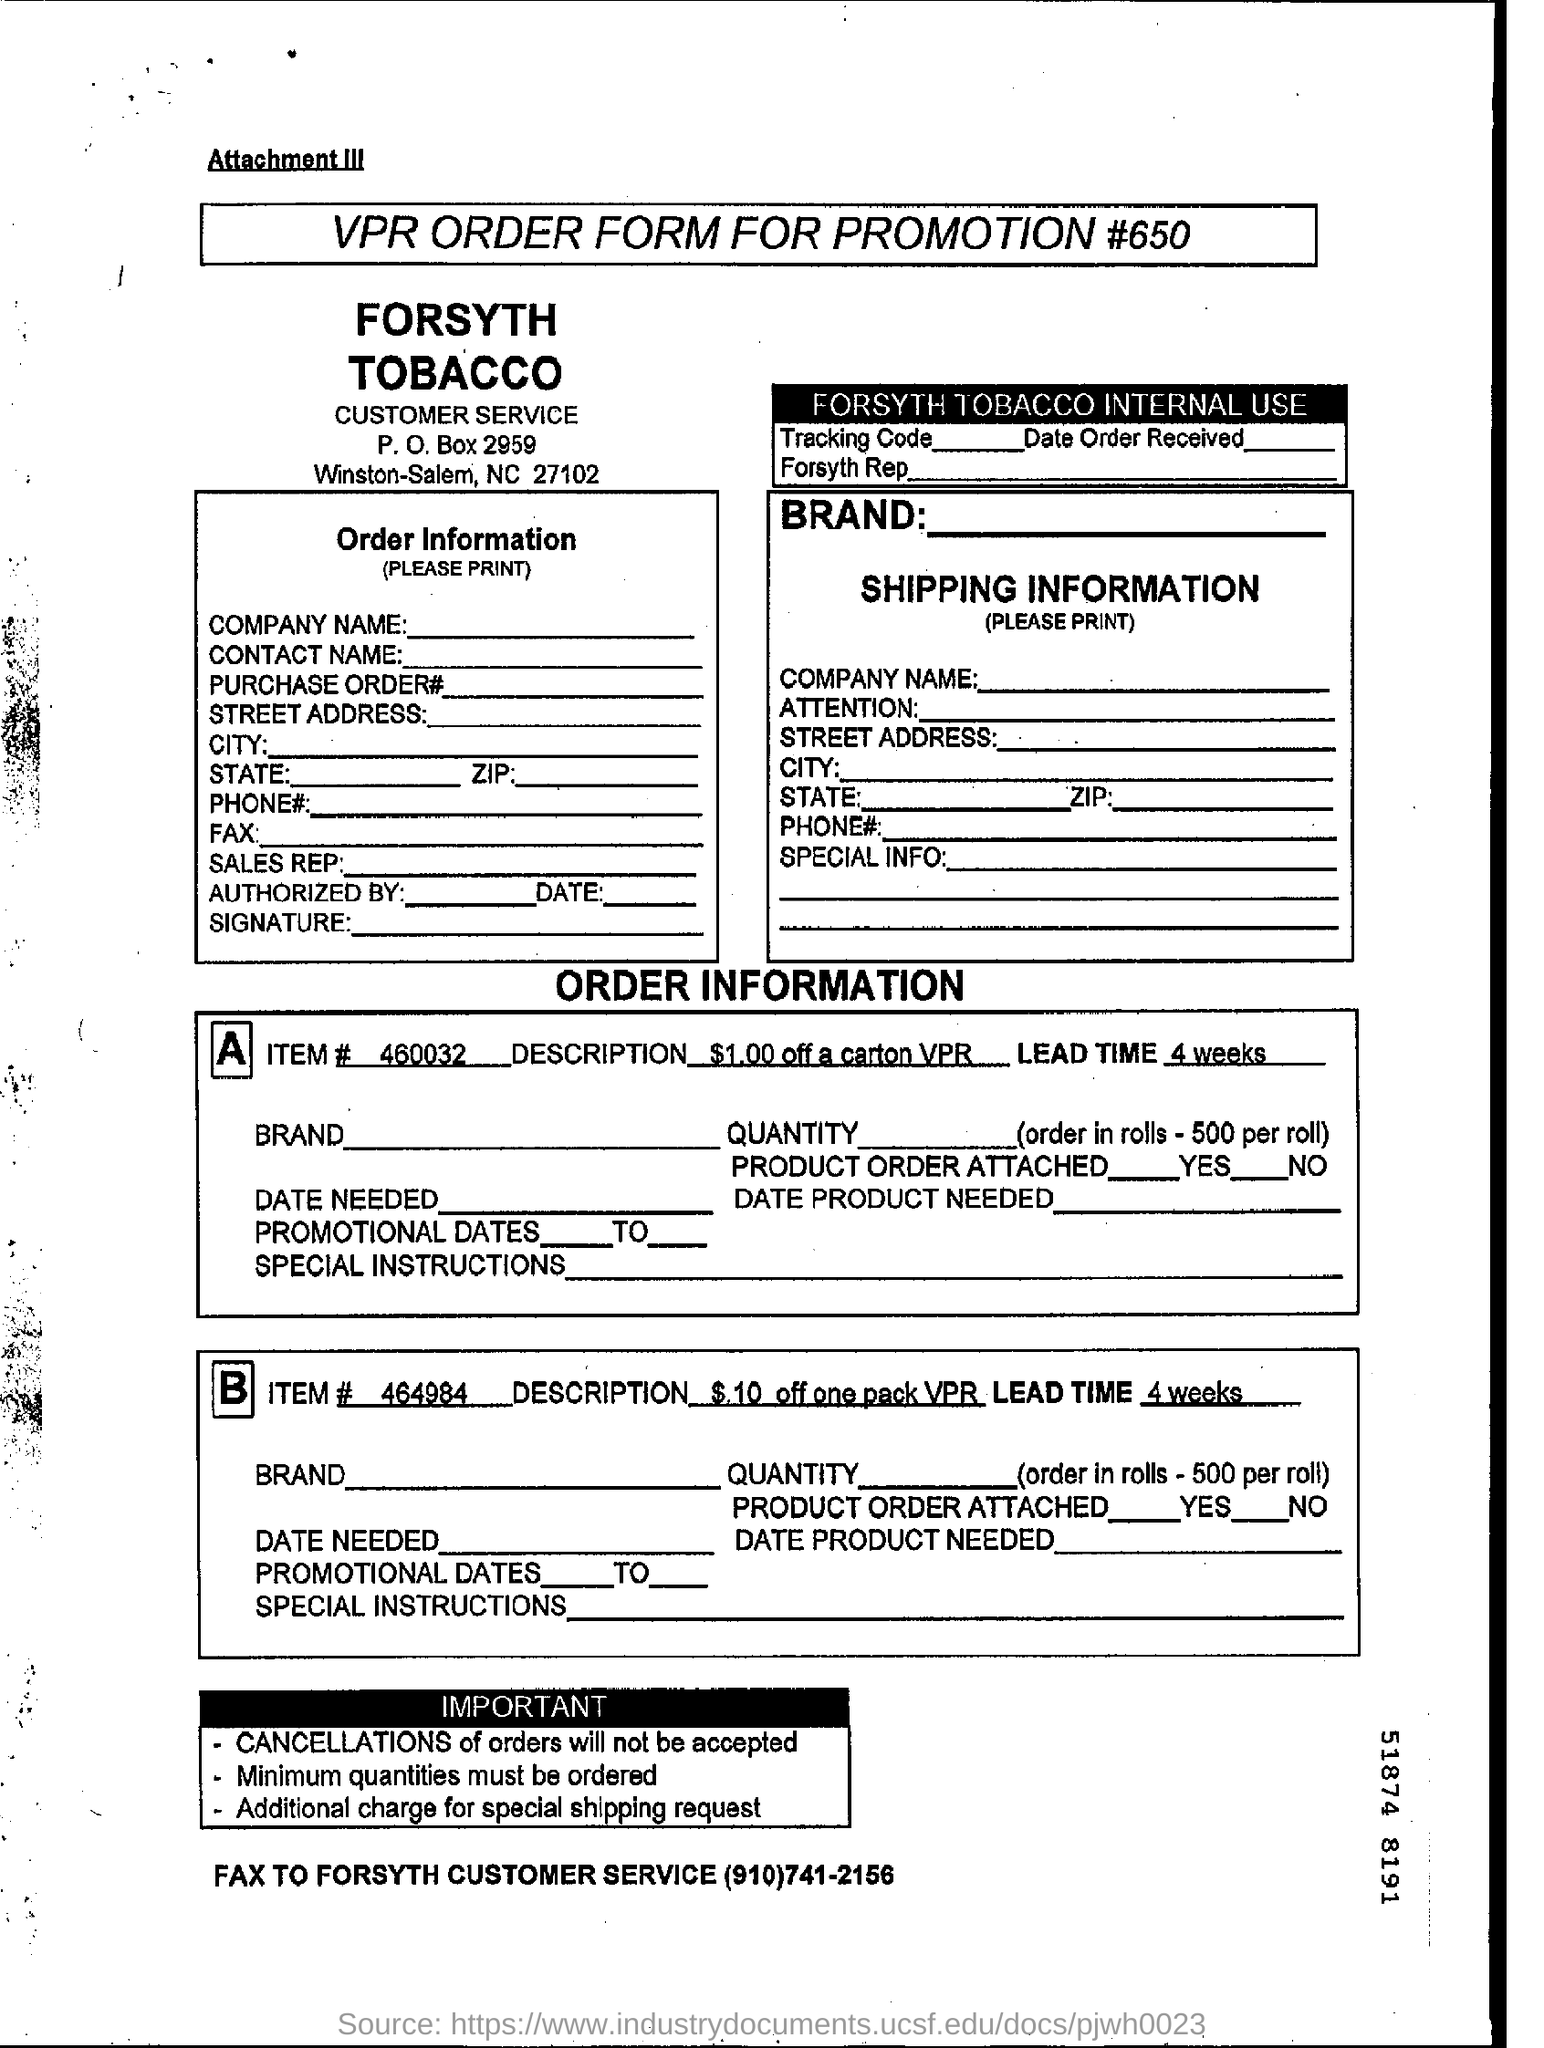What is the description of item # 460032?
Make the answer very short. $1.00 off a carton VPR. What is the lead time of item # 464984?
Your answer should be very brief. 4 weeks. What is the Fax number of Forsyth customer service given?
Offer a terse response. (910)741-2156. What is the document title?
Provide a short and direct response. VPR ORDER FORM FOR PROMOTION #650. 